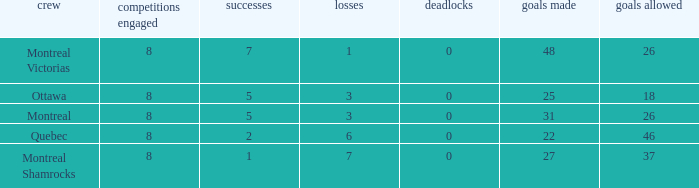How many losses did the team with 22 goals for andmore than 8 games played have? 0.0. 